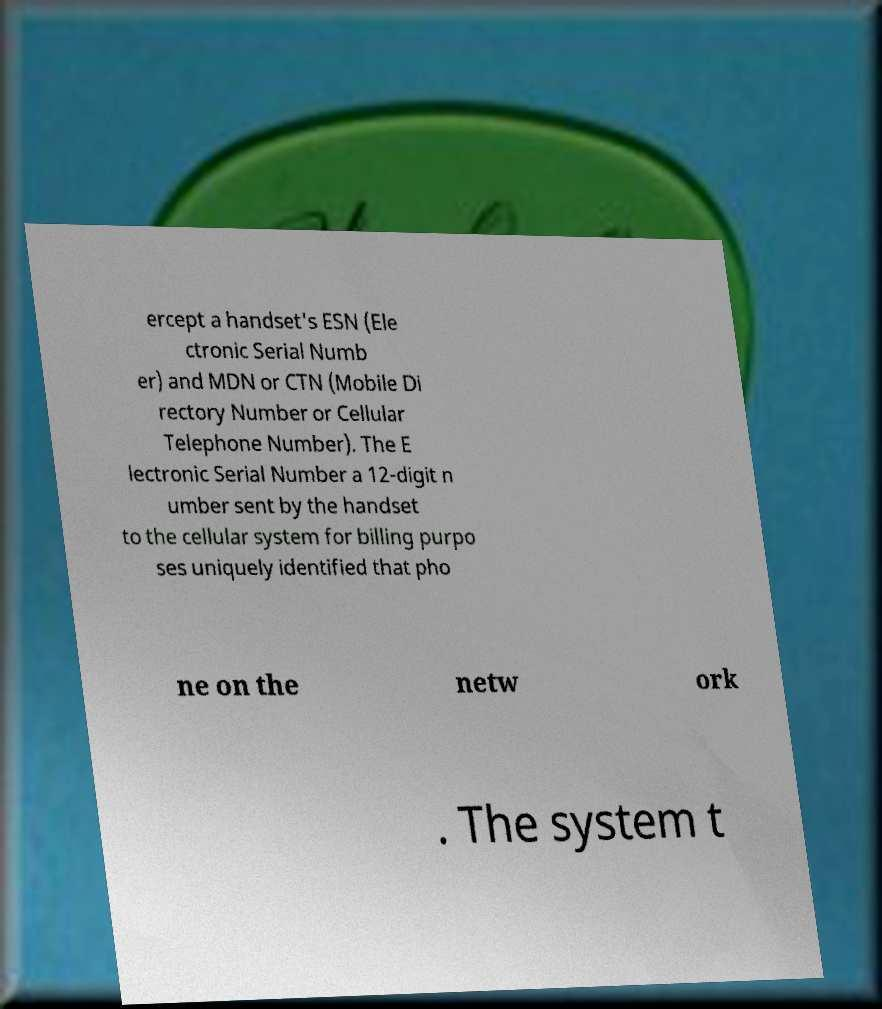What messages or text are displayed in this image? I need them in a readable, typed format. ercept a handset's ESN (Ele ctronic Serial Numb er) and MDN or CTN (Mobile Di rectory Number or Cellular Telephone Number). The E lectronic Serial Number a 12-digit n umber sent by the handset to the cellular system for billing purpo ses uniquely identified that pho ne on the netw ork . The system t 